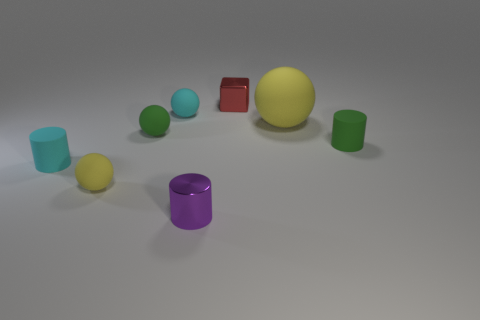Subtract all green matte cylinders. How many cylinders are left? 2 Subtract all cyan balls. How many balls are left? 3 Add 2 large yellow spheres. How many objects exist? 10 Subtract all gray spheres. Subtract all red blocks. How many spheres are left? 4 Add 3 cubes. How many cubes exist? 4 Subtract 1 green cylinders. How many objects are left? 7 Subtract all cylinders. How many objects are left? 5 Subtract all yellow metal things. Subtract all shiny things. How many objects are left? 6 Add 6 cyan matte spheres. How many cyan matte spheres are left? 7 